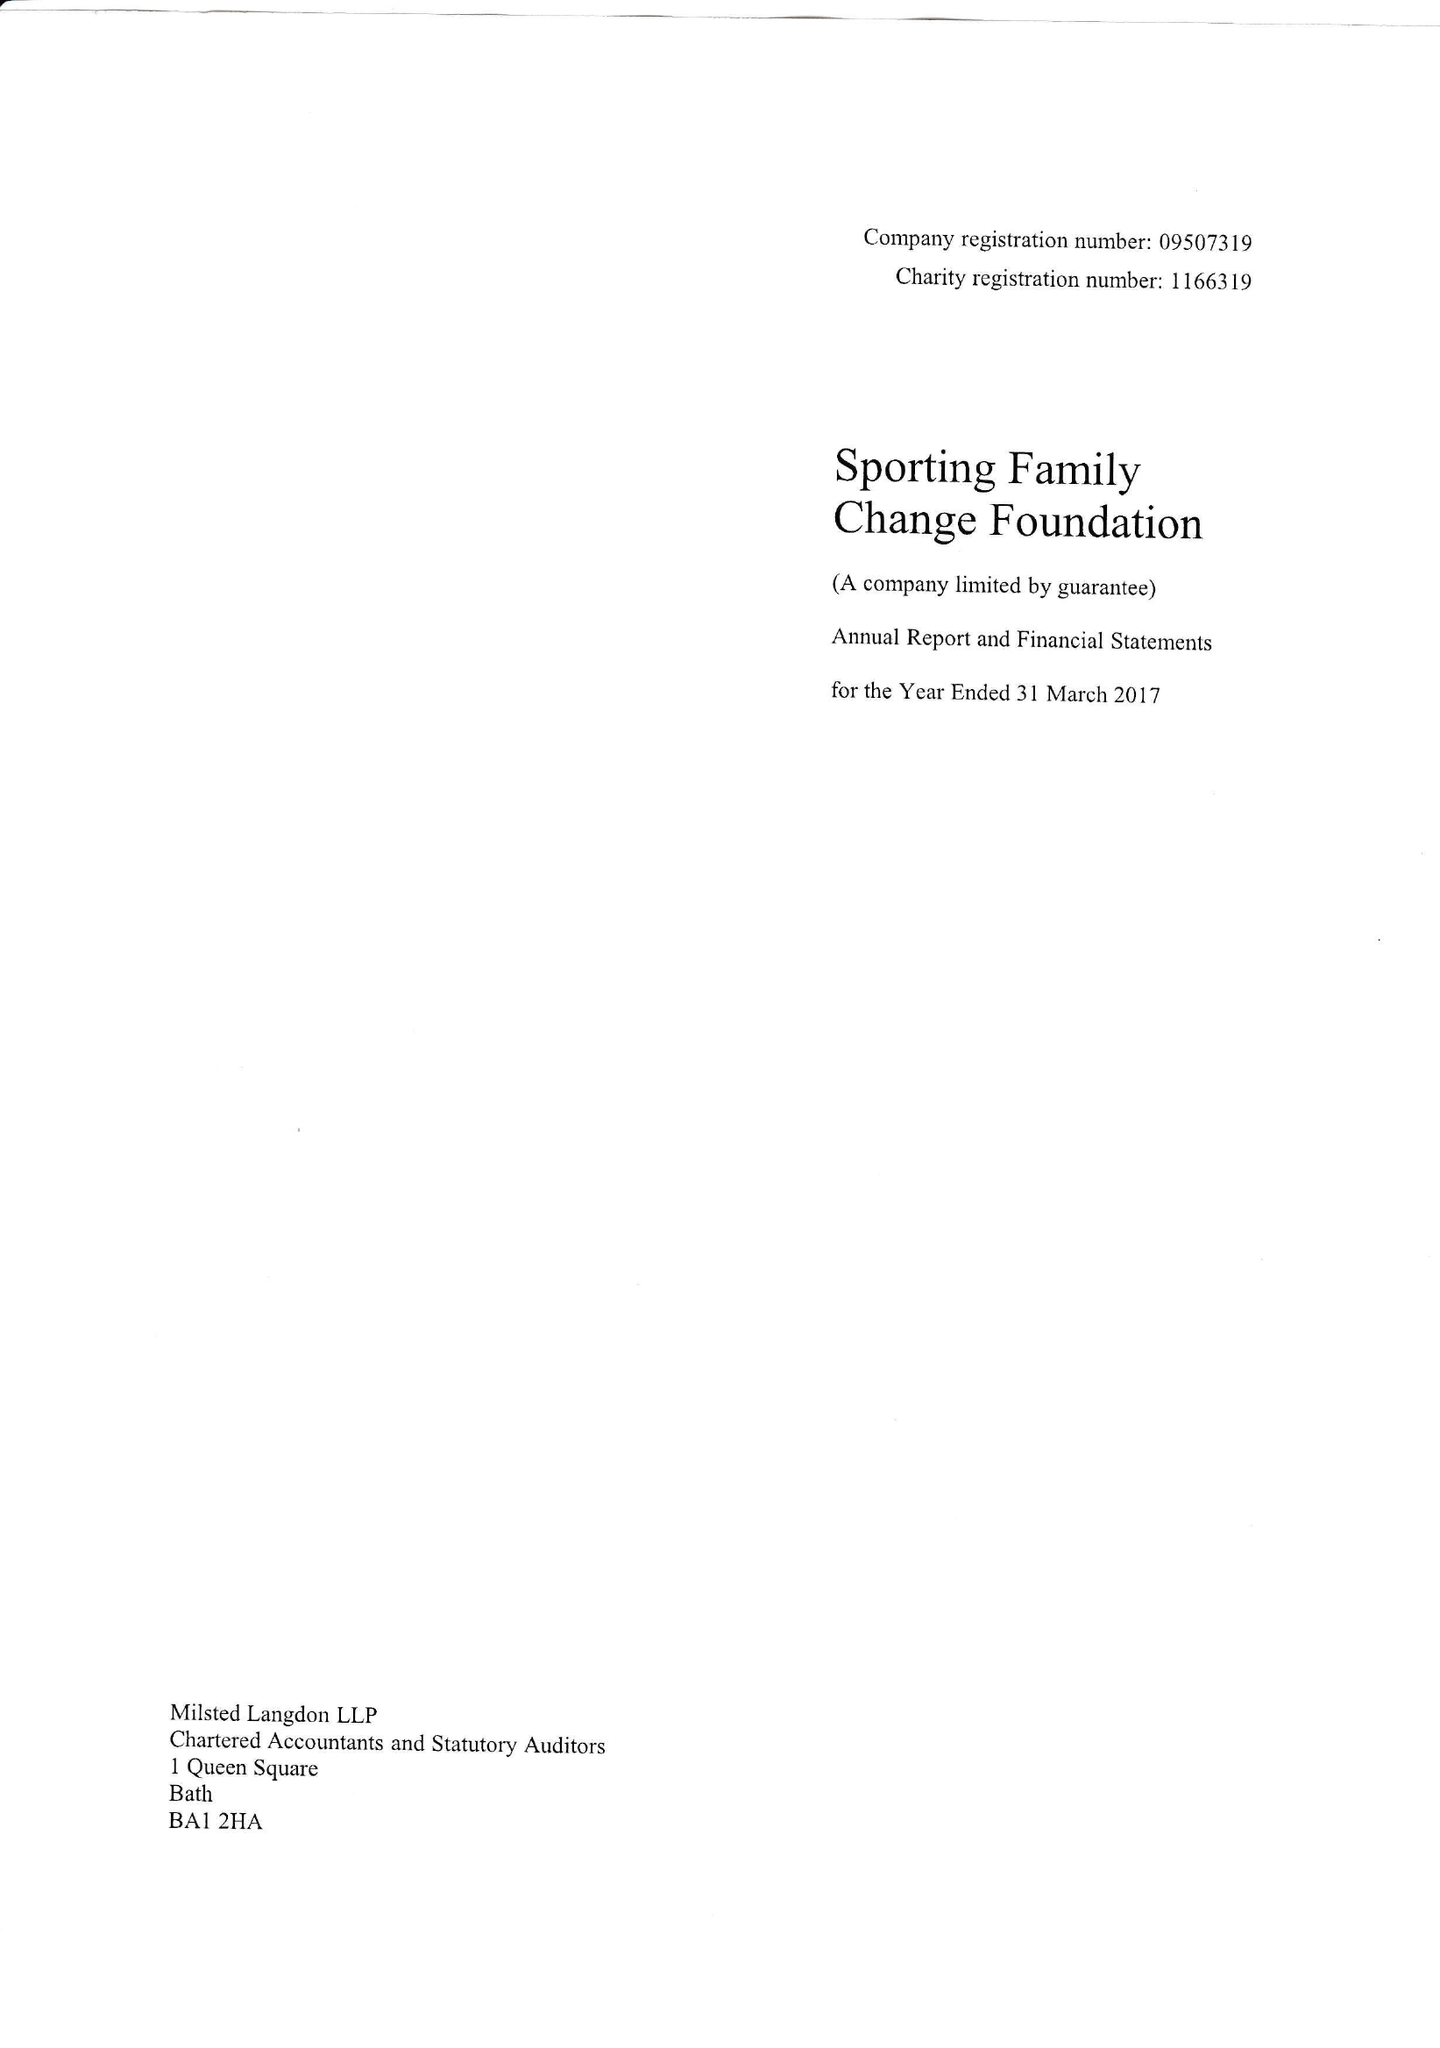What is the value for the address__post_town?
Answer the question using a single word or phrase. BATH 